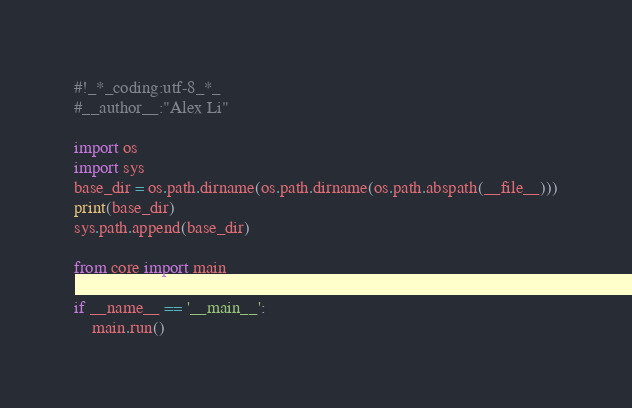Convert code to text. <code><loc_0><loc_0><loc_500><loc_500><_Python_>#!_*_coding:utf-8_*_
#__author__:"Alex Li"

import os
import sys
base_dir = os.path.dirname(os.path.dirname(os.path.abspath(__file__)))
print(base_dir)
sys.path.append(base_dir)

from core import main

if __name__ == '__main__':
    main.run()
</code> 